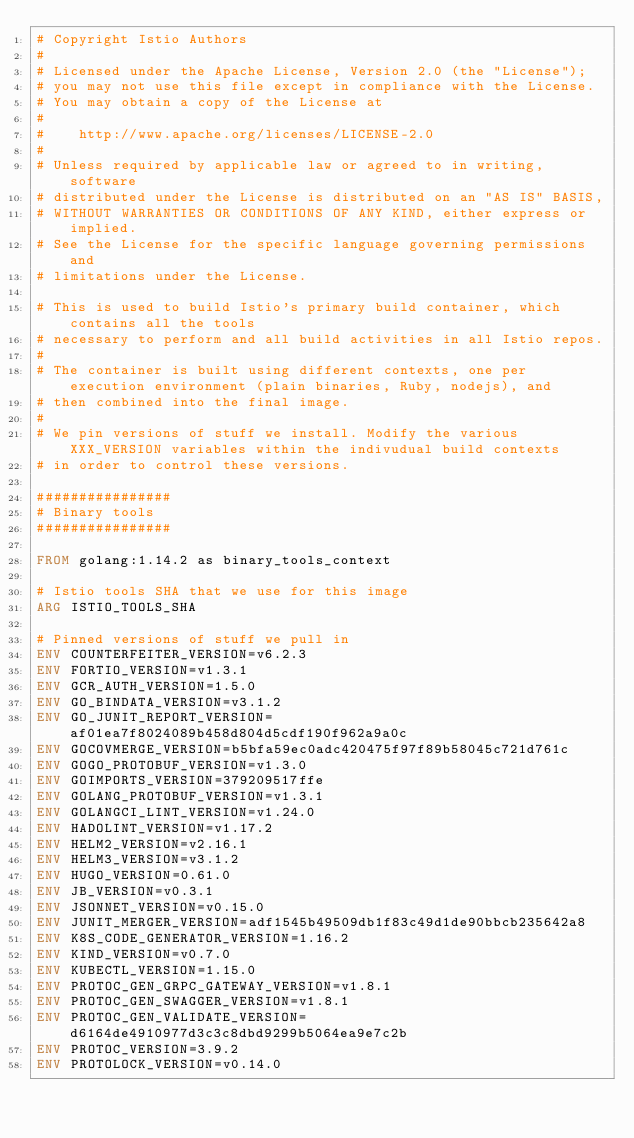<code> <loc_0><loc_0><loc_500><loc_500><_Dockerfile_># Copyright Istio Authors
#
# Licensed under the Apache License, Version 2.0 (the "License");
# you may not use this file except in compliance with the License.
# You may obtain a copy of the License at
#
#    http://www.apache.org/licenses/LICENSE-2.0
#
# Unless required by applicable law or agreed to in writing, software
# distributed under the License is distributed on an "AS IS" BASIS,
# WITHOUT WARRANTIES OR CONDITIONS OF ANY KIND, either express or implied.
# See the License for the specific language governing permissions and
# limitations under the License.

# This is used to build Istio's primary build container, which contains all the tools
# necessary to perform and all build activities in all Istio repos.
#
# The container is built using different contexts, one per execution environment (plain binaries, Ruby, nodejs), and
# then combined into the final image.
#
# We pin versions of stuff we install. Modify the various XXX_VERSION variables within the indivudual build contexts
# in order to control these versions.

################
# Binary tools
################

FROM golang:1.14.2 as binary_tools_context

# Istio tools SHA that we use for this image
ARG ISTIO_TOOLS_SHA

# Pinned versions of stuff we pull in
ENV COUNTERFEITER_VERSION=v6.2.3
ENV FORTIO_VERSION=v1.3.1
ENV GCR_AUTH_VERSION=1.5.0
ENV GO_BINDATA_VERSION=v3.1.2
ENV GO_JUNIT_REPORT_VERSION=af01ea7f8024089b458d804d5cdf190f962a9a0c
ENV GOCOVMERGE_VERSION=b5bfa59ec0adc420475f97f89b58045c721d761c
ENV GOGO_PROTOBUF_VERSION=v1.3.0
ENV GOIMPORTS_VERSION=379209517ffe
ENV GOLANG_PROTOBUF_VERSION=v1.3.1
ENV GOLANGCI_LINT_VERSION=v1.24.0
ENV HADOLINT_VERSION=v1.17.2
ENV HELM2_VERSION=v2.16.1
ENV HELM3_VERSION=v3.1.2
ENV HUGO_VERSION=0.61.0
ENV JB_VERSION=v0.3.1
ENV JSONNET_VERSION=v0.15.0
ENV JUNIT_MERGER_VERSION=adf1545b49509db1f83c49d1de90bbcb235642a8
ENV K8S_CODE_GENERATOR_VERSION=1.16.2
ENV KIND_VERSION=v0.7.0
ENV KUBECTL_VERSION=1.15.0
ENV PROTOC_GEN_GRPC_GATEWAY_VERSION=v1.8.1
ENV PROTOC_GEN_SWAGGER_VERSION=v1.8.1
ENV PROTOC_GEN_VALIDATE_VERSION=d6164de4910977d3c3c8dbd9299b5064ea9e7c2b
ENV PROTOC_VERSION=3.9.2
ENV PROTOLOCK_VERSION=v0.14.0</code> 